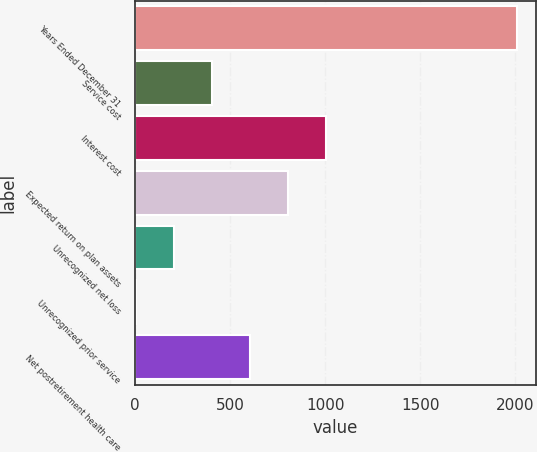Convert chart. <chart><loc_0><loc_0><loc_500><loc_500><bar_chart><fcel>Years Ended December 31<fcel>Service cost<fcel>Interest cost<fcel>Expected return on plan assets<fcel>Unrecognized net loss<fcel>Unrecognized prior service<fcel>Net postretirement health care<nl><fcel>2007<fcel>403<fcel>1004.5<fcel>804<fcel>202.5<fcel>2<fcel>603.5<nl></chart> 